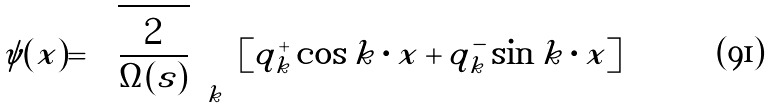Convert formula to latex. <formula><loc_0><loc_0><loc_500><loc_500>\psi ( { x } ) = \sqrt { \frac { 2 } { \Omega ( s ) } } \sum _ { k } [ q _ { k } ^ { + } \cos { k } \cdot { x } + q _ { k } ^ { - } \sin { k } \cdot { x } ]</formula> 